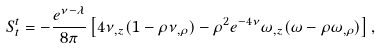<formula> <loc_0><loc_0><loc_500><loc_500>S ^ { t } _ { t } = - \frac { e ^ { \nu - \lambda } } { 8 \pi } \left [ 4 \nu _ { , z } ( 1 - \rho \nu _ { , \rho } ) - \rho ^ { 2 } e ^ { - 4 \nu } \omega _ { , z } ( \omega - \rho \omega _ { , \rho } ) \right ] ,</formula> 